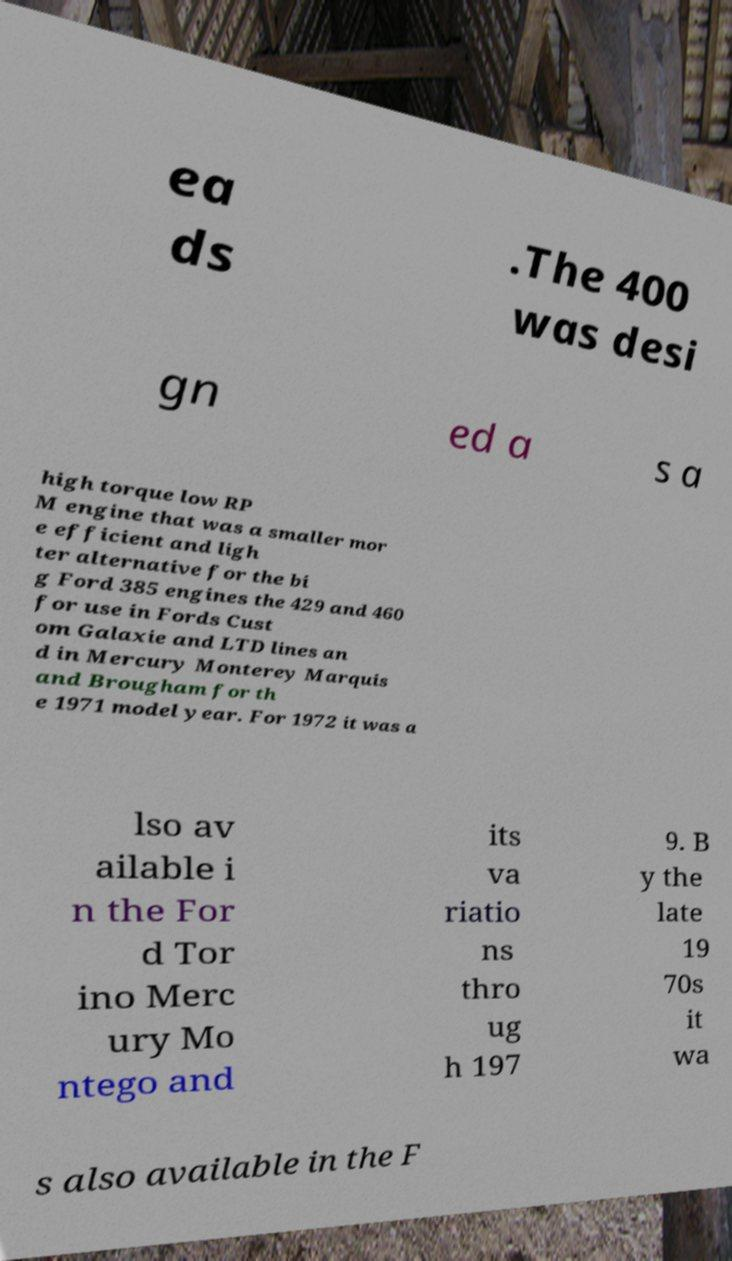What messages or text are displayed in this image? I need them in a readable, typed format. ea ds .The 400 was desi gn ed a s a high torque low RP M engine that was a smaller mor e efficient and ligh ter alternative for the bi g Ford 385 engines the 429 and 460 for use in Fords Cust om Galaxie and LTD lines an d in Mercury Monterey Marquis and Brougham for th e 1971 model year. For 1972 it was a lso av ailable i n the For d Tor ino Merc ury Mo ntego and its va riatio ns thro ug h 197 9. B y the late 19 70s it wa s also available in the F 